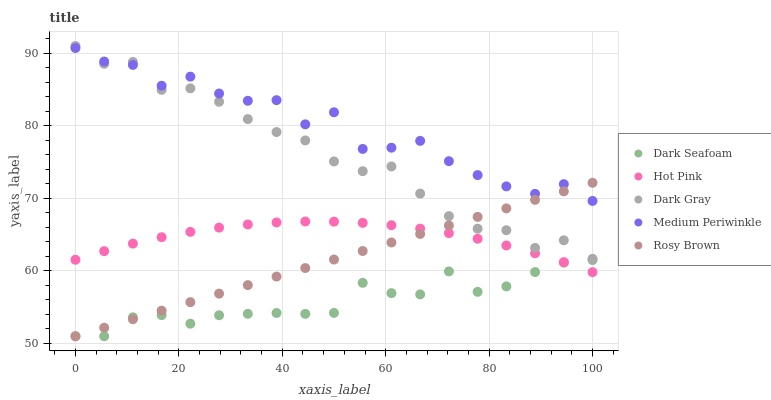Does Dark Seafoam have the minimum area under the curve?
Answer yes or no. Yes. Does Medium Periwinkle have the maximum area under the curve?
Answer yes or no. Yes. Does Hot Pink have the minimum area under the curve?
Answer yes or no. No. Does Hot Pink have the maximum area under the curve?
Answer yes or no. No. Is Rosy Brown the smoothest?
Answer yes or no. Yes. Is Medium Periwinkle the roughest?
Answer yes or no. Yes. Is Dark Seafoam the smoothest?
Answer yes or no. No. Is Dark Seafoam the roughest?
Answer yes or no. No. Does Dark Seafoam have the lowest value?
Answer yes or no. Yes. Does Hot Pink have the lowest value?
Answer yes or no. No. Does Dark Gray have the highest value?
Answer yes or no. Yes. Does Hot Pink have the highest value?
Answer yes or no. No. Is Hot Pink less than Dark Gray?
Answer yes or no. Yes. Is Dark Gray greater than Dark Seafoam?
Answer yes or no. Yes. Does Rosy Brown intersect Dark Gray?
Answer yes or no. Yes. Is Rosy Brown less than Dark Gray?
Answer yes or no. No. Is Rosy Brown greater than Dark Gray?
Answer yes or no. No. Does Hot Pink intersect Dark Gray?
Answer yes or no. No. 